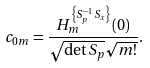Convert formula to latex. <formula><loc_0><loc_0><loc_500><loc_500>c _ { { 0 } { m } } = \frac { H ^ { \left \{ S ^ { - 1 } _ { p } S _ { x } \right \} } _ { m } ( 0 ) } { \sqrt { \det S _ { p } } \sqrt { { m } ! } } .</formula> 